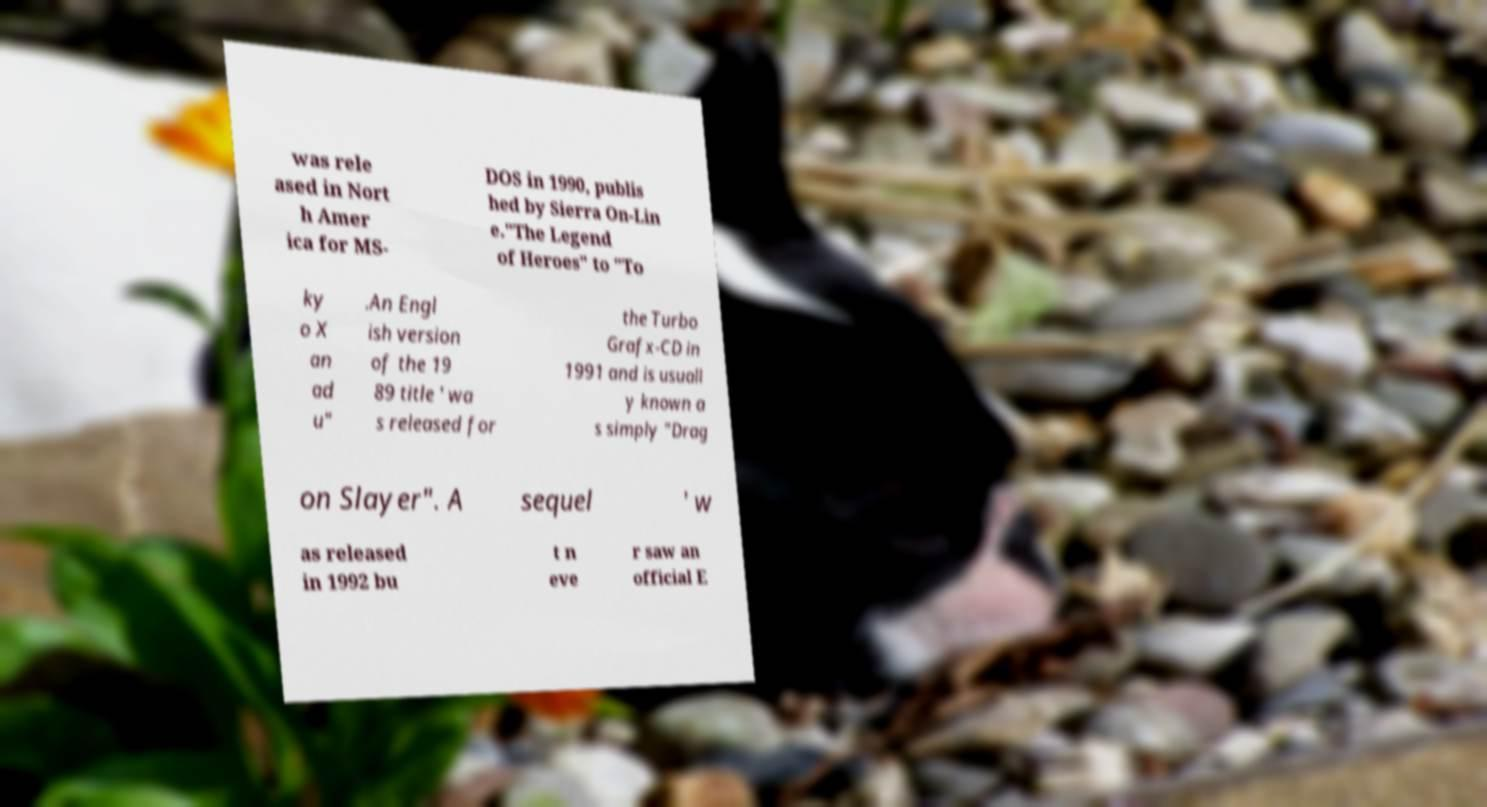Could you assist in decoding the text presented in this image and type it out clearly? was rele ased in Nort h Amer ica for MS- DOS in 1990, publis hed by Sierra On-Lin e."The Legend of Heroes" to "To ky o X an ad u" .An Engl ish version of the 19 89 title ' wa s released for the Turbo Grafx-CD in 1991 and is usuall y known a s simply "Drag on Slayer". A sequel ' w as released in 1992 bu t n eve r saw an official E 